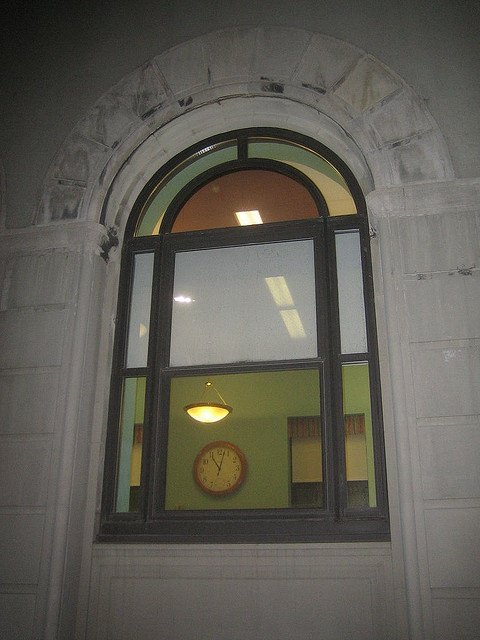Describe the objects in this image and their specific colors. I can see a clock in black, olive, and maroon tones in this image. 